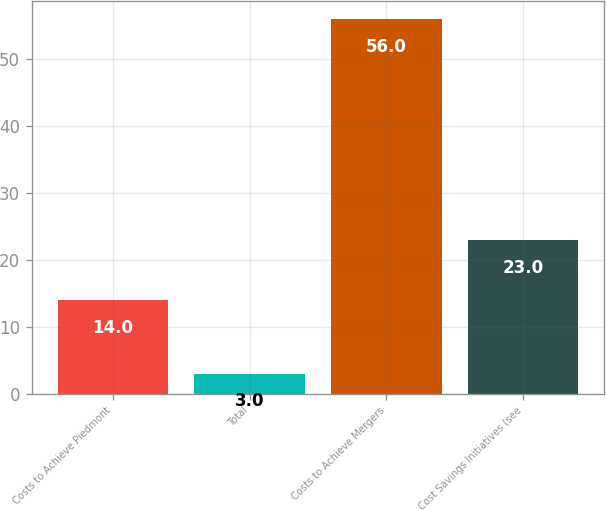<chart> <loc_0><loc_0><loc_500><loc_500><bar_chart><fcel>Costs to Achieve Piedmont<fcel>Total<fcel>Costs to Achieve Mergers<fcel>Cost Savings Initiatives (see<nl><fcel>14<fcel>3<fcel>56<fcel>23<nl></chart> 